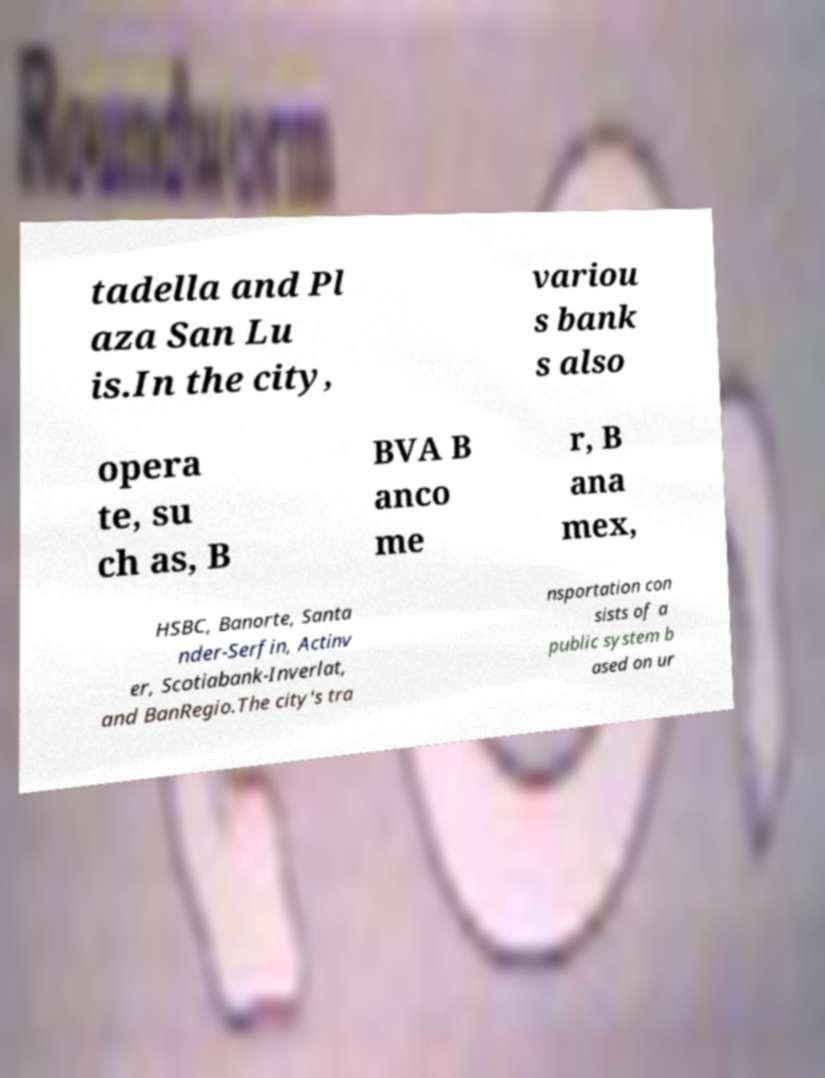Can you read and provide the text displayed in the image?This photo seems to have some interesting text. Can you extract and type it out for me? tadella and Pl aza San Lu is.In the city, variou s bank s also opera te, su ch as, B BVA B anco me r, B ana mex, HSBC, Banorte, Santa nder-Serfin, Actinv er, Scotiabank-Inverlat, and BanRegio.The city's tra nsportation con sists of a public system b ased on ur 